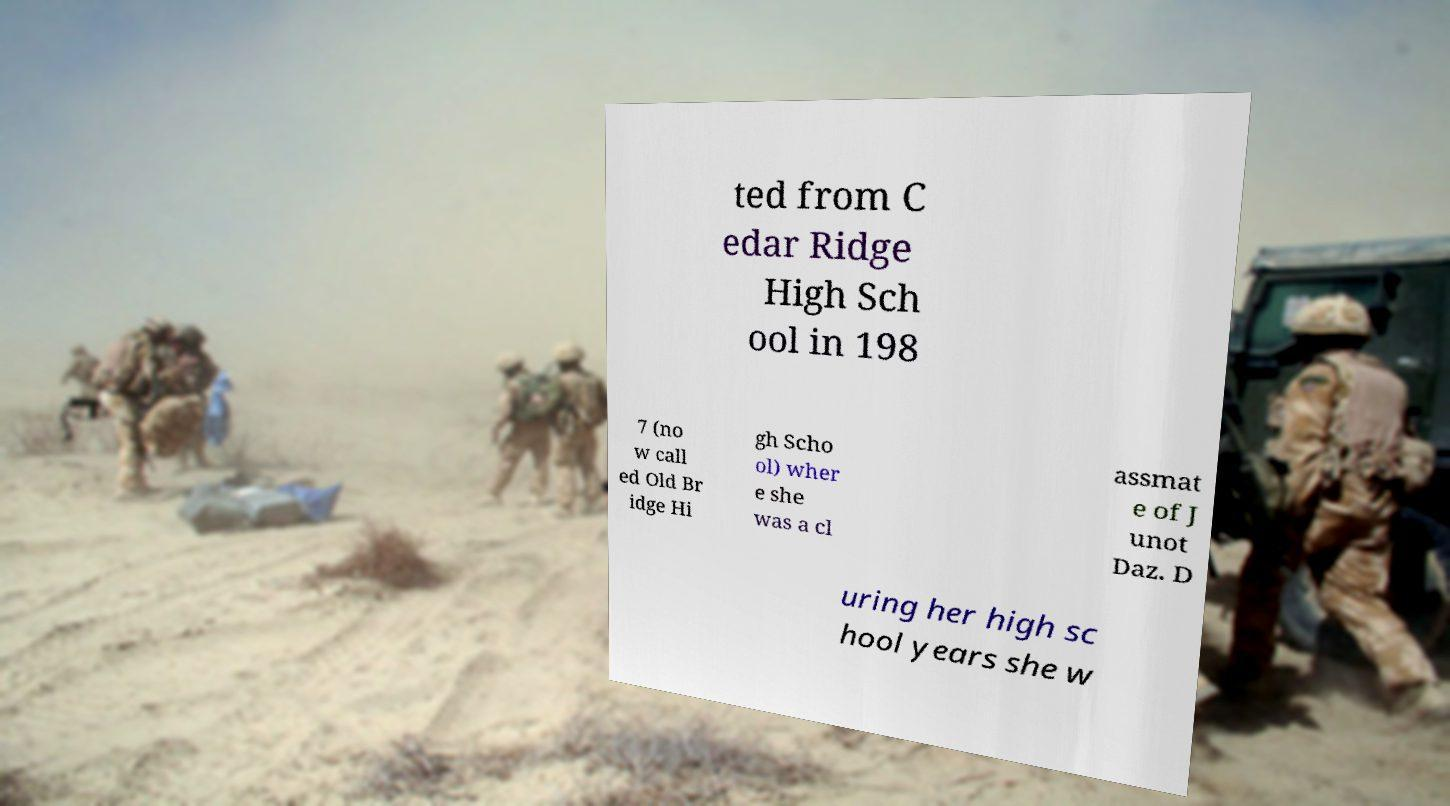Please read and relay the text visible in this image. What does it say? ted from C edar Ridge High Sch ool in 198 7 (no w call ed Old Br idge Hi gh Scho ol) wher e she was a cl assmat e of J unot Daz. D uring her high sc hool years she w 